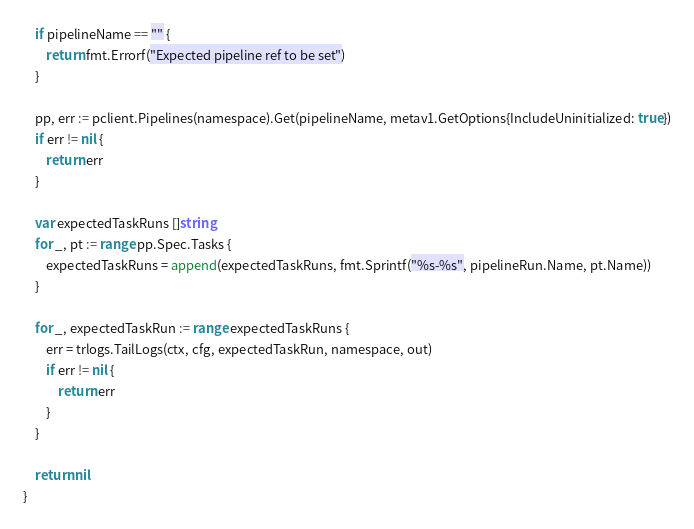<code> <loc_0><loc_0><loc_500><loc_500><_Go_>	if pipelineName == "" {
		return fmt.Errorf("Expected pipeline ref to be set")
	}

	pp, err := pclient.Pipelines(namespace).Get(pipelineName, metav1.GetOptions{IncludeUninitialized: true})
	if err != nil {
		return err
	}

	var expectedTaskRuns []string
	for _, pt := range pp.Spec.Tasks {
		expectedTaskRuns = append(expectedTaskRuns, fmt.Sprintf("%s-%s", pipelineRun.Name, pt.Name))
	}

	for _, expectedTaskRun := range expectedTaskRuns {
		err = trlogs.TailLogs(ctx, cfg, expectedTaskRun, namespace, out)
		if err != nil {
			return err
		}
	}

	return nil
}
</code> 